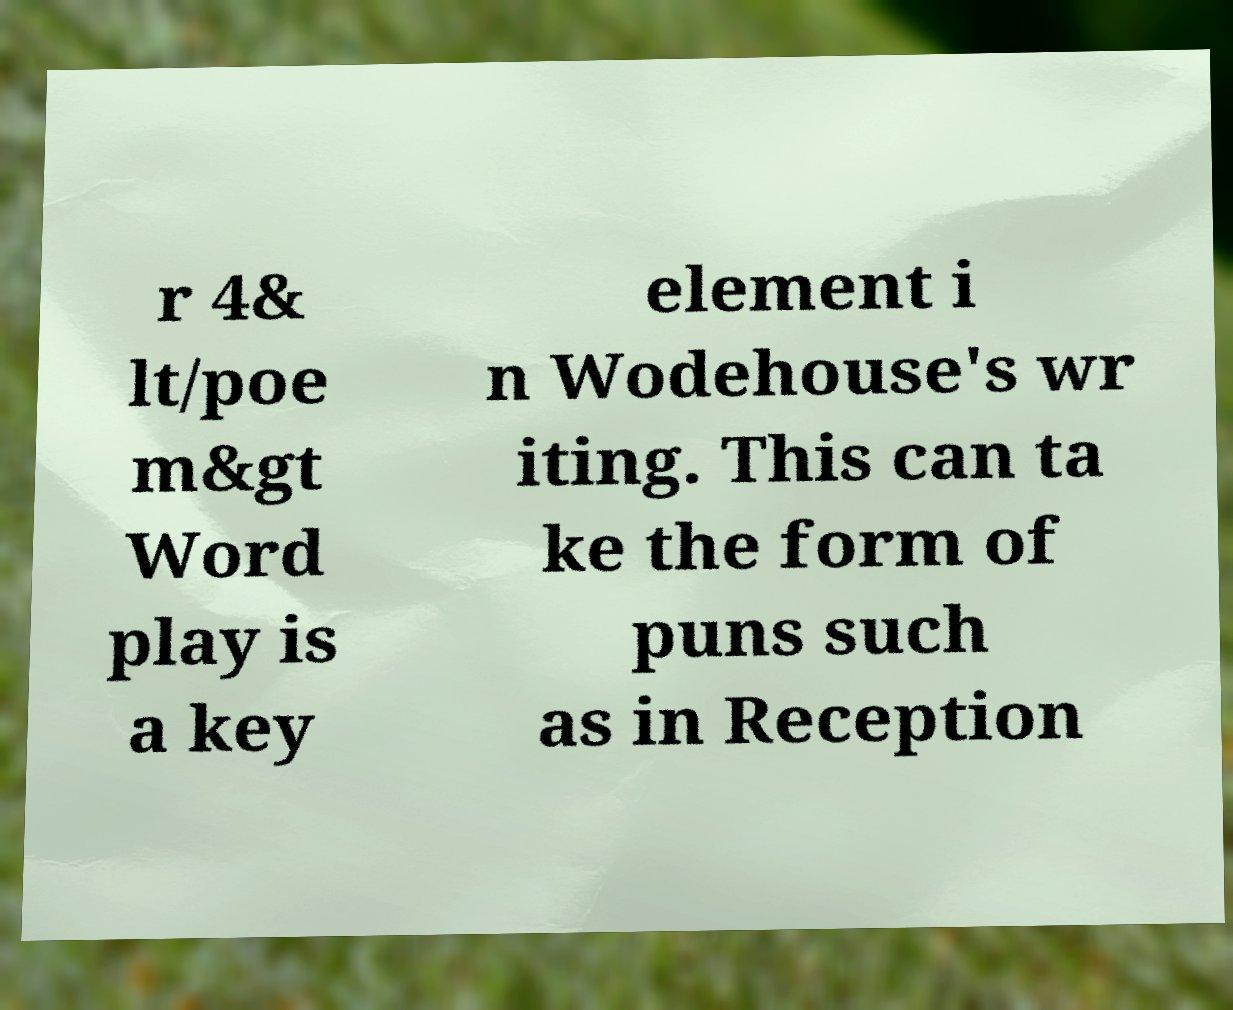Could you assist in decoding the text presented in this image and type it out clearly? r 4& lt/poe m&gt Word play is a key element i n Wodehouse's wr iting. This can ta ke the form of puns such as in Reception 